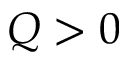Convert formula to latex. <formula><loc_0><loc_0><loc_500><loc_500>Q > 0</formula> 